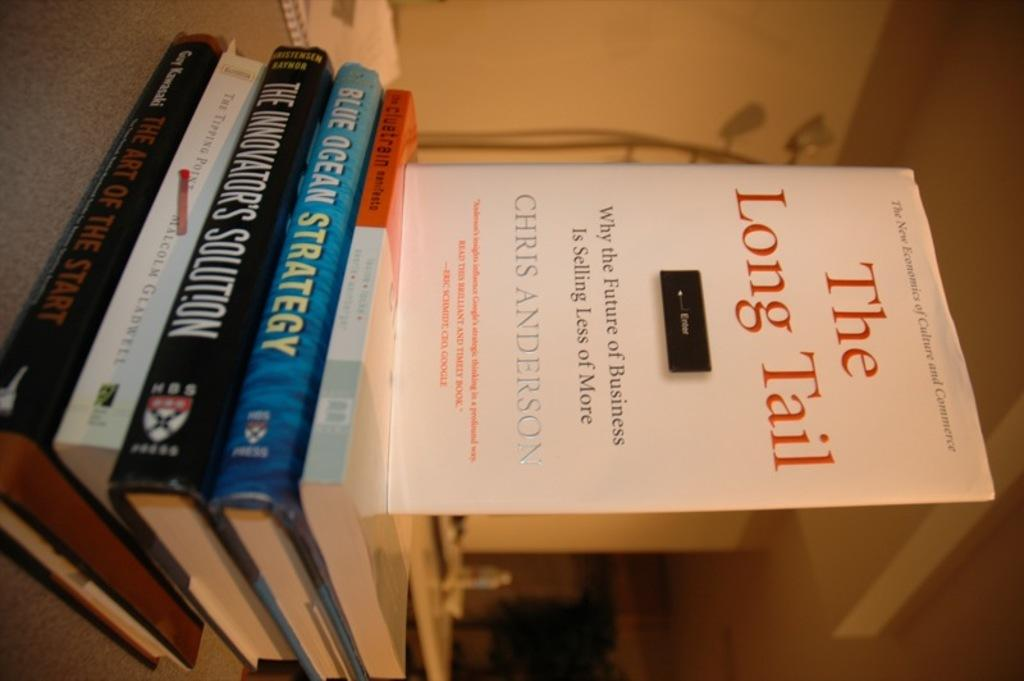<image>
Present a compact description of the photo's key features. Several books including one called The Long Tail. 